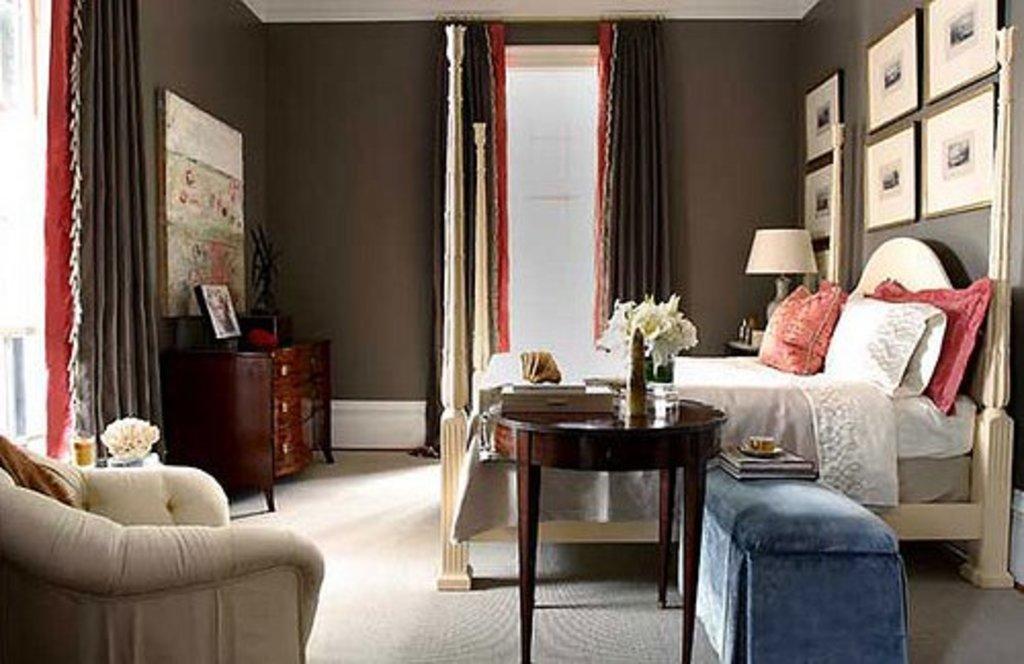Could you give a brief overview of what you see in this image? In this image we can see the sofa chair, table on which flower vase is kept, we can see the books and cup are kept here, we can see a bed with pillows on it and with a blanket, we can see wooden cupboard upon which we can see photo frame is placed, we can see table lamp, photo frames on the wall and curtains in the background. 